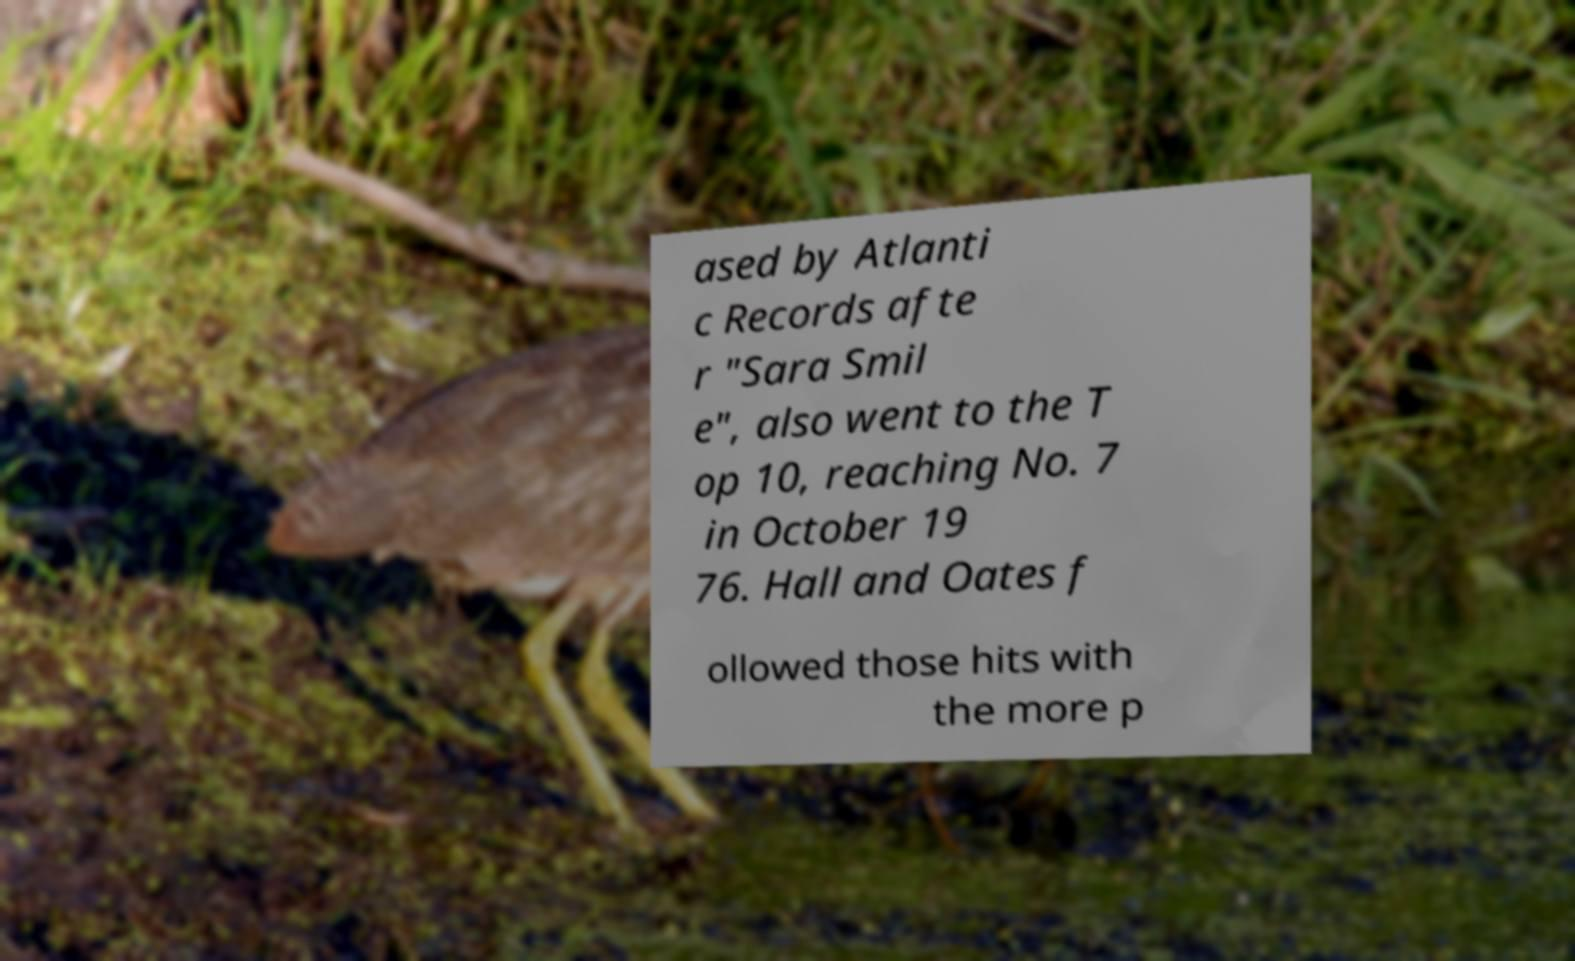Could you assist in decoding the text presented in this image and type it out clearly? ased by Atlanti c Records afte r "Sara Smil e", also went to the T op 10, reaching No. 7 in October 19 76. Hall and Oates f ollowed those hits with the more p 